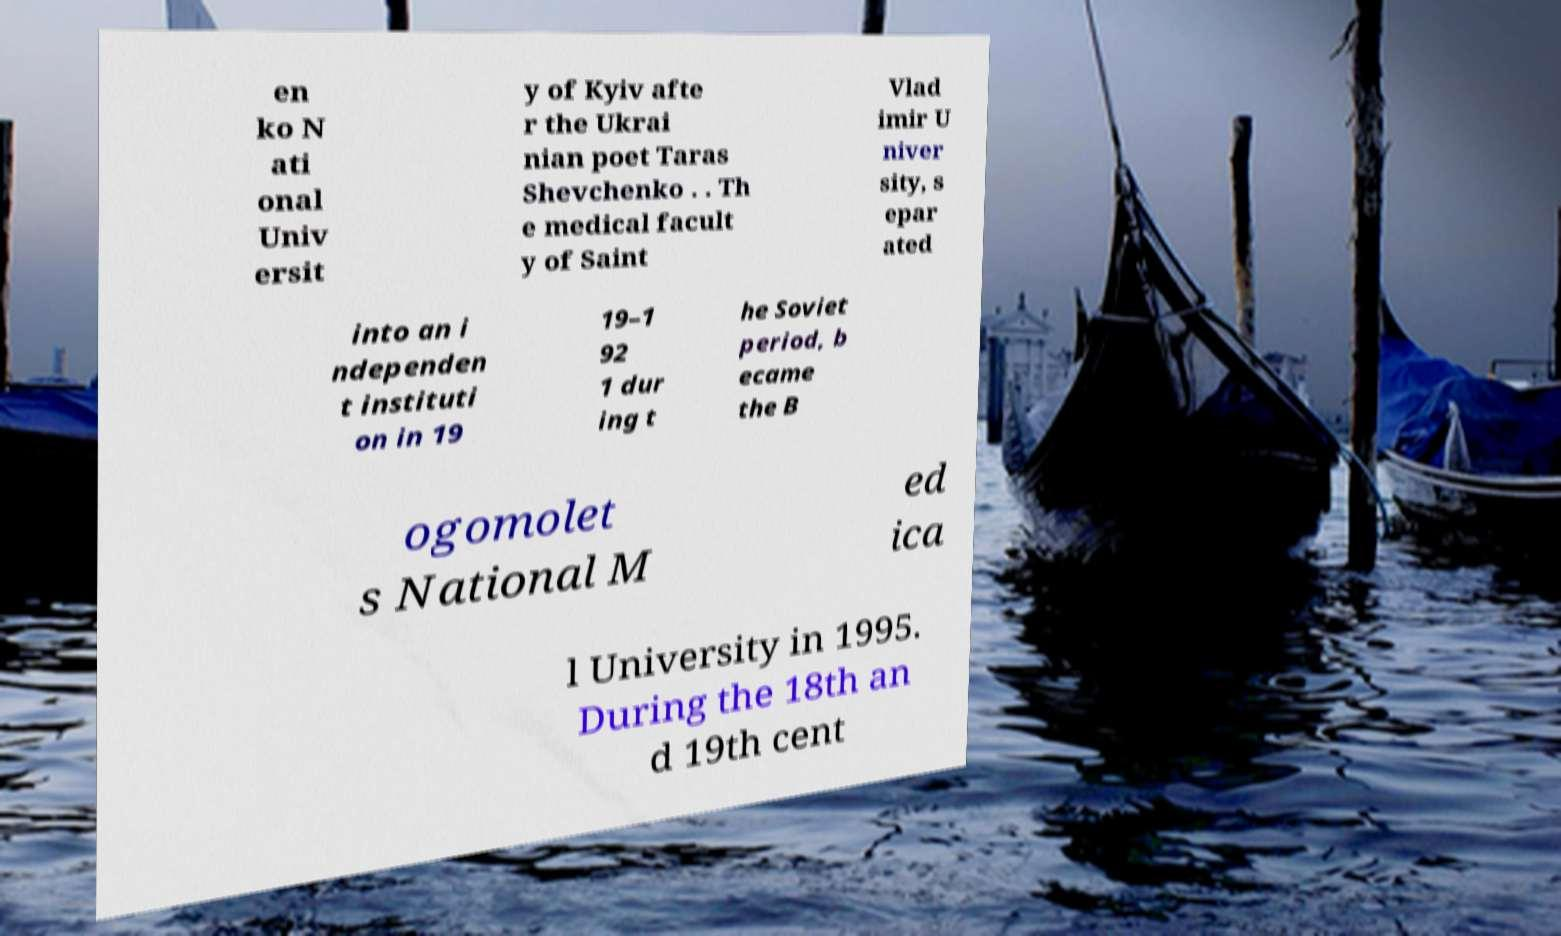Please read and relay the text visible in this image. What does it say? en ko N ati onal Univ ersit y of Kyiv afte r the Ukrai nian poet Taras Shevchenko . . Th e medical facult y of Saint Vlad imir U niver sity, s epar ated into an i ndependen t instituti on in 19 19–1 92 1 dur ing t he Soviet period, b ecame the B ogomolet s National M ed ica l University in 1995. During the 18th an d 19th cent 